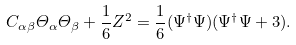<formula> <loc_0><loc_0><loc_500><loc_500>C _ { \alpha \beta } \varTheta _ { \alpha } \varTheta _ { \beta } + \frac { 1 } { 6 } Z ^ { 2 } = \frac { 1 } { 6 } ( \Psi ^ { \dagger } \Psi ) ( \Psi ^ { \dagger } \Psi + 3 ) .</formula> 